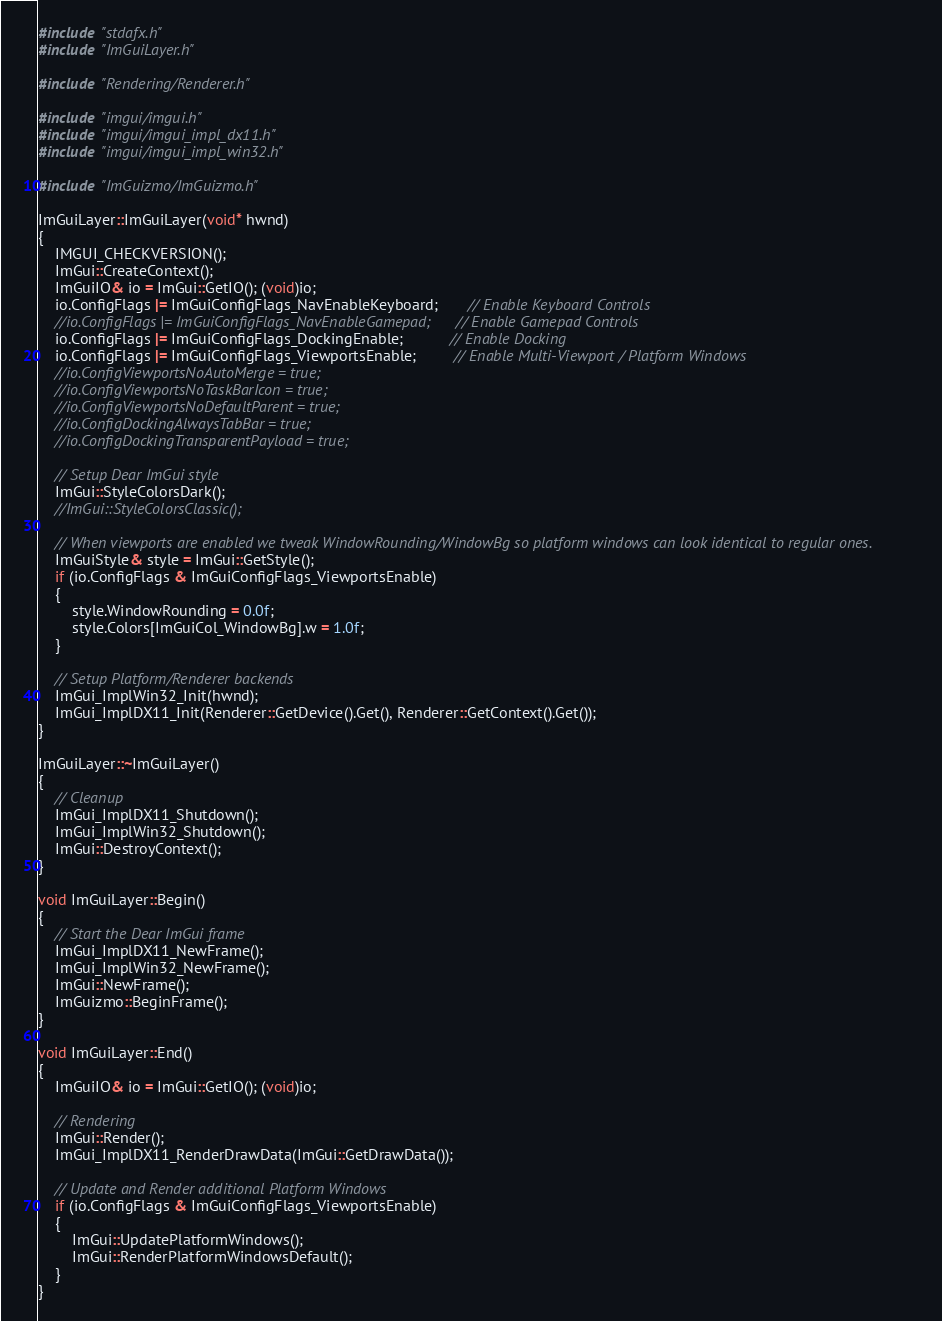<code> <loc_0><loc_0><loc_500><loc_500><_C++_>#include "stdafx.h"
#include "ImGuiLayer.h"

#include "Rendering/Renderer.h"

#include "imgui/imgui.h"
#include "imgui/imgui_impl_dx11.h"
#include "imgui/imgui_impl_win32.h"

#include "ImGuizmo/ImGuizmo.h"

ImGuiLayer::ImGuiLayer(void* hwnd)
{
    IMGUI_CHECKVERSION();
    ImGui::CreateContext();
    ImGuiIO& io = ImGui::GetIO(); (void)io;
    io.ConfigFlags |= ImGuiConfigFlags_NavEnableKeyboard;       // Enable Keyboard Controls
    //io.ConfigFlags |= ImGuiConfigFlags_NavEnableGamepad;      // Enable Gamepad Controls
    io.ConfigFlags |= ImGuiConfigFlags_DockingEnable;           // Enable Docking
    io.ConfigFlags |= ImGuiConfigFlags_ViewportsEnable;         // Enable Multi-Viewport / Platform Windows
    //io.ConfigViewportsNoAutoMerge = true;
    //io.ConfigViewportsNoTaskBarIcon = true;
    //io.ConfigViewportsNoDefaultParent = true;
    //io.ConfigDockingAlwaysTabBar = true;
    //io.ConfigDockingTransparentPayload = true;

    // Setup Dear ImGui style
    ImGui::StyleColorsDark();
    //ImGui::StyleColorsClassic();

    // When viewports are enabled we tweak WindowRounding/WindowBg so platform windows can look identical to regular ones.
    ImGuiStyle& style = ImGui::GetStyle();
    if (io.ConfigFlags & ImGuiConfigFlags_ViewportsEnable)
    {
        style.WindowRounding = 0.0f;
        style.Colors[ImGuiCol_WindowBg].w = 1.0f;
    }

    // Setup Platform/Renderer backends
    ImGui_ImplWin32_Init(hwnd);
    ImGui_ImplDX11_Init(Renderer::GetDevice().Get(), Renderer::GetContext().Get());
}

ImGuiLayer::~ImGuiLayer()
{
    // Cleanup
    ImGui_ImplDX11_Shutdown();
    ImGui_ImplWin32_Shutdown();
    ImGui::DestroyContext();
}

void ImGuiLayer::Begin()
{
    // Start the Dear ImGui frame
    ImGui_ImplDX11_NewFrame();
    ImGui_ImplWin32_NewFrame();
    ImGui::NewFrame();
    ImGuizmo::BeginFrame();
}

void ImGuiLayer::End()
{
    ImGuiIO& io = ImGui::GetIO(); (void)io;
	
    // Rendering
    ImGui::Render();
    ImGui_ImplDX11_RenderDrawData(ImGui::GetDrawData());

    // Update and Render additional Platform Windows
    if (io.ConfigFlags & ImGuiConfigFlags_ViewportsEnable)
    {
        ImGui::UpdatePlatformWindows();
        ImGui::RenderPlatformWindowsDefault();
    }
}
</code> 